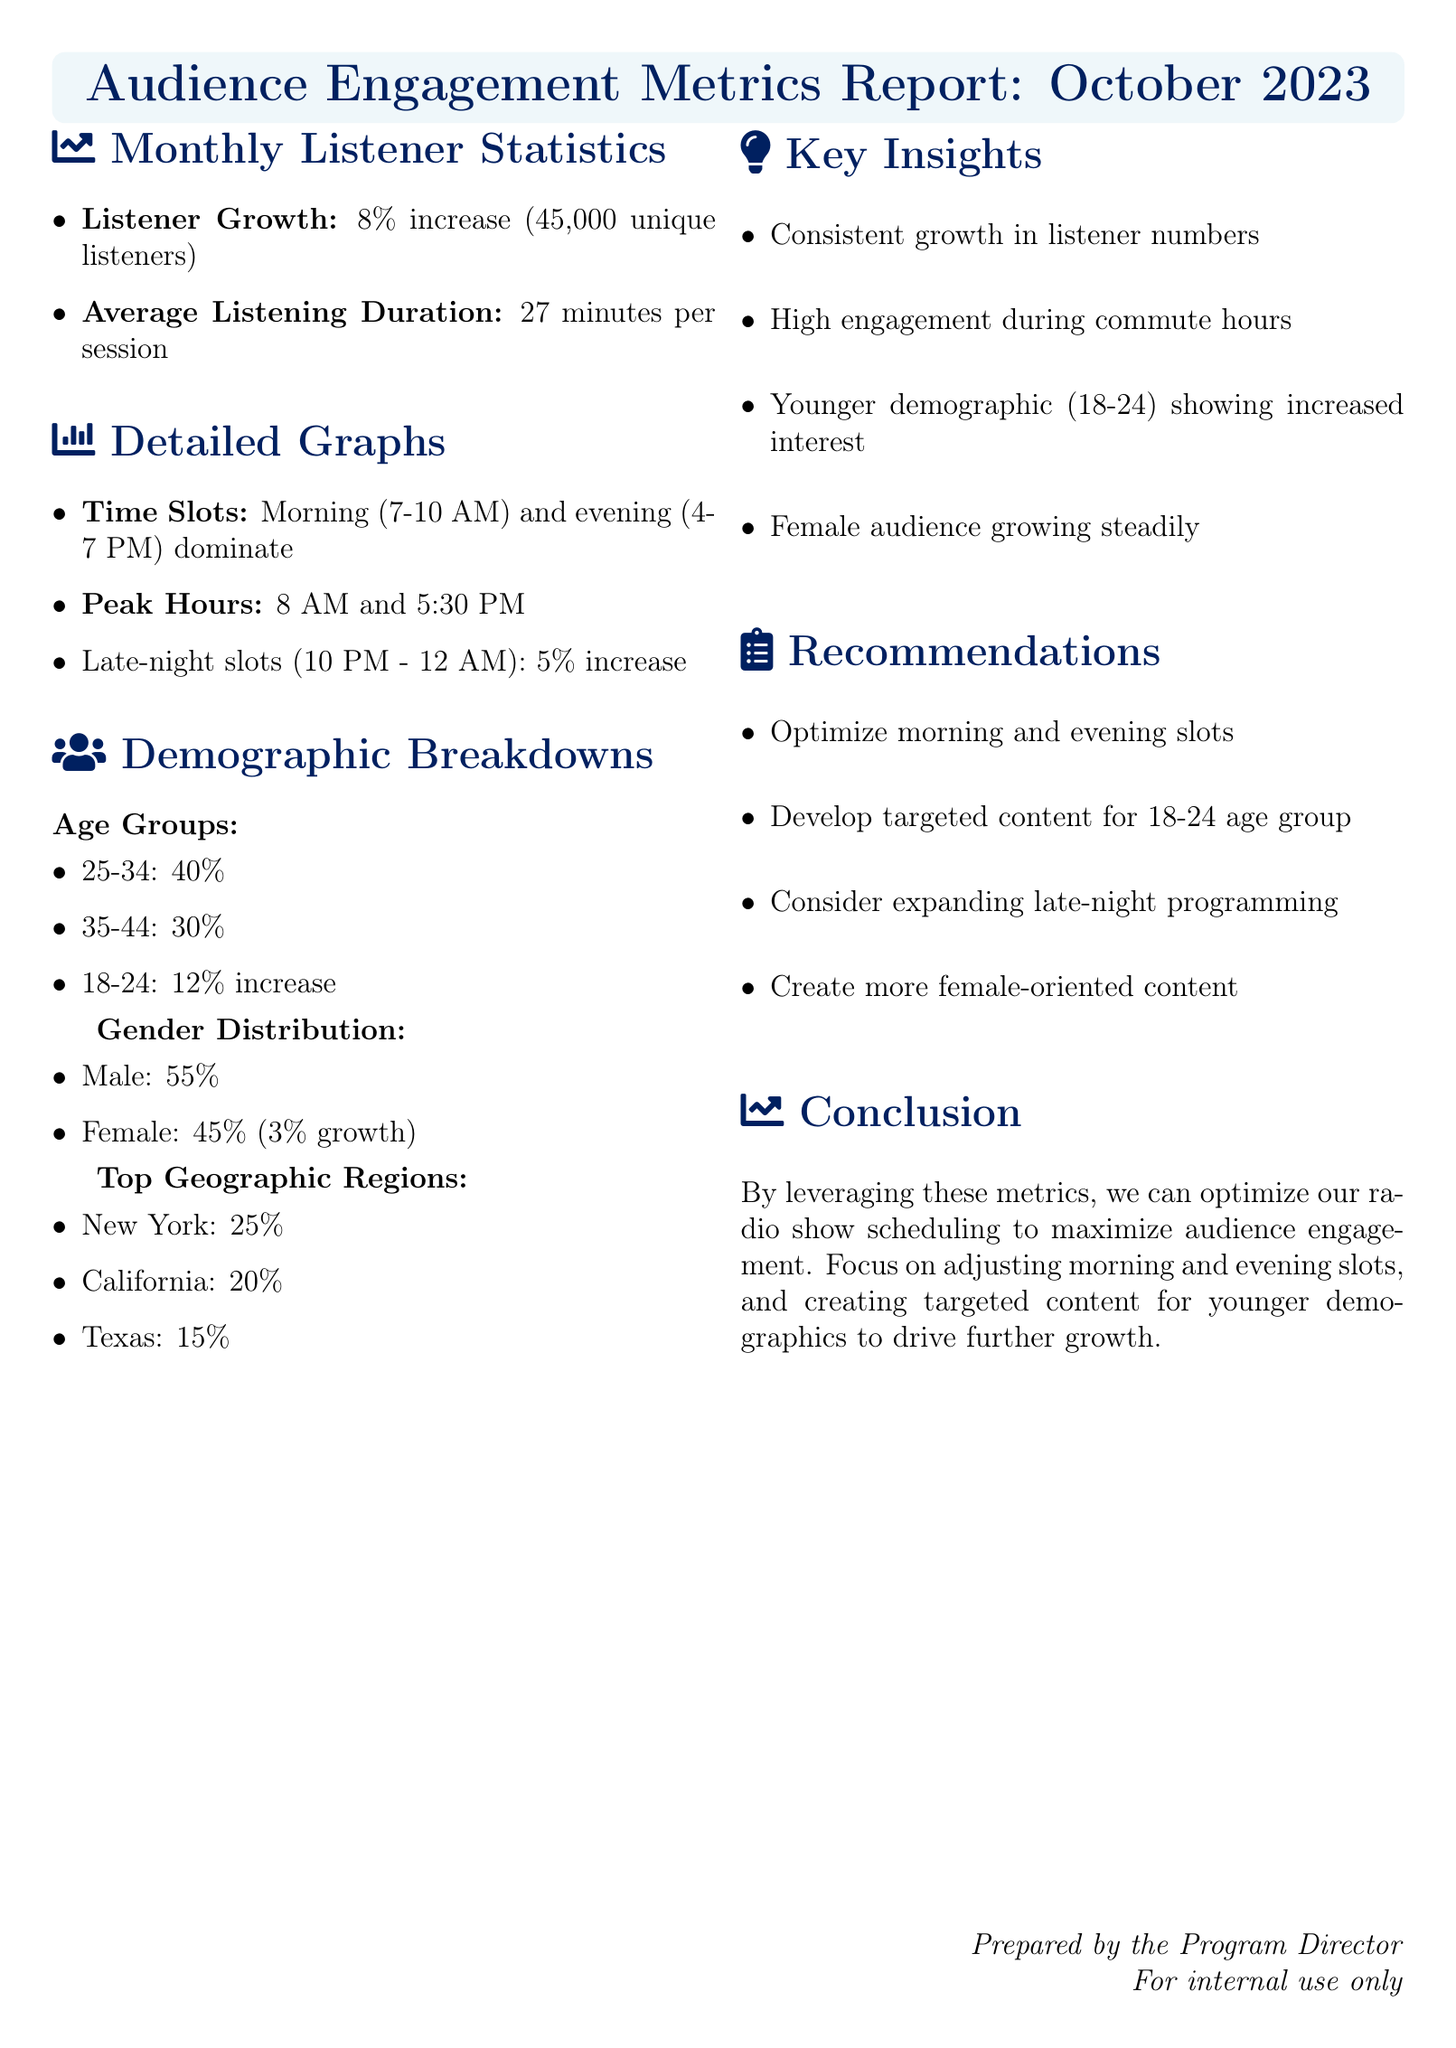What is the listener growth percentage? The listener growth percentage is specified in the document as an 8% increase.
Answer: 8% What is the average listening duration? The document states the average listening duration is 27 minutes per session.
Answer: 27 minutes What are the peak listening hours? The peak listening hours are noted as 8 AM and 5:30 PM in the document.
Answer: 8 AM and 5:30 PM What percentage of listeners are from the 25-34 age group? The document specifies that 40% of listeners are from the 25-34 age group.
Answer: 40% What is the percentage increase in the female audience? The document states there is a 3% growth in the female audience.
Answer: 3% Which age group shows a 12% increase? The document mentions that the 18-24 age group is showing a 12% increase.
Answer: 18-24 Which geographic region has the highest listener percentage? The highest listener percentage is from New York, as noted in the document.
Answer: New York What recommendation is made for late-night programming? The document recommends considering expanding late-night programming.
Answer: Expand late-night programming Which demographic is suggested for targeted content development? The document suggests developing targeted content for the 18-24 age group.
Answer: 18-24 age group 